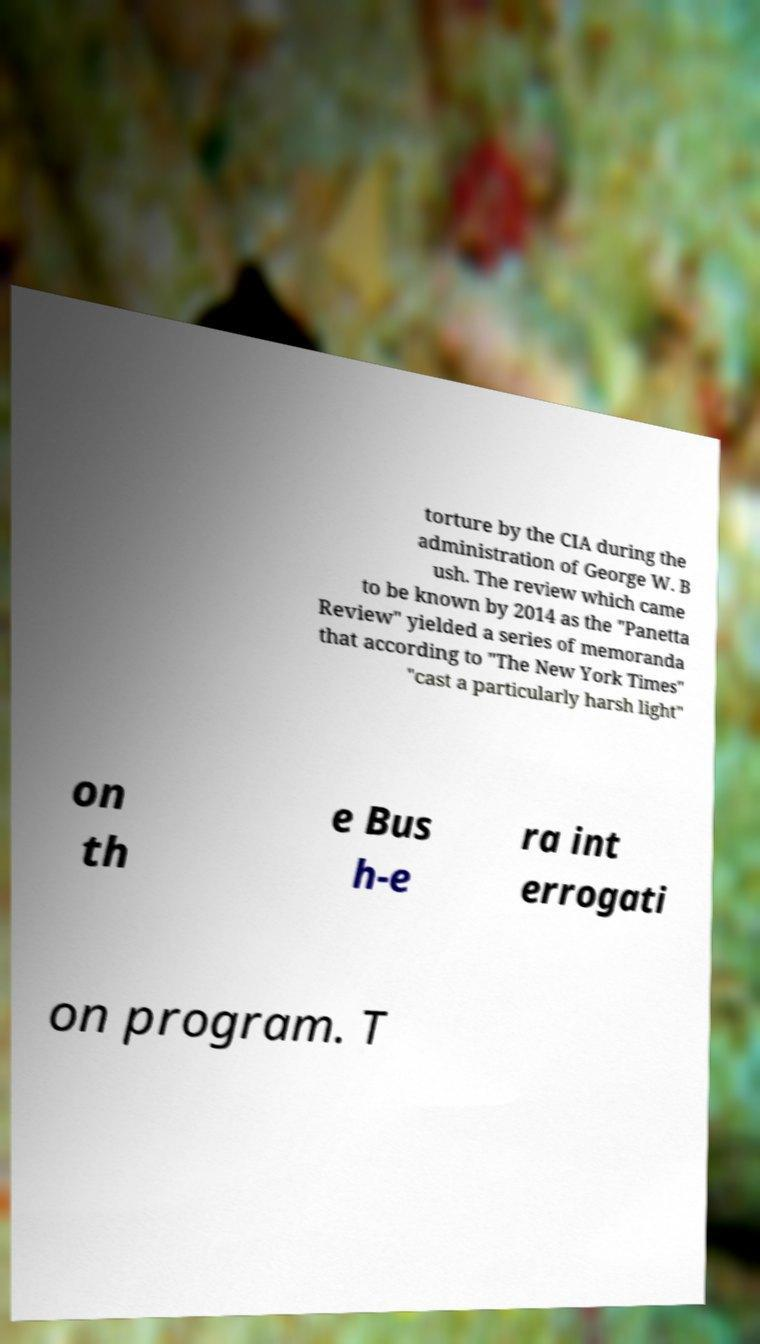Could you extract and type out the text from this image? torture by the CIA during the administration of George W. B ush. The review which came to be known by 2014 as the "Panetta Review" yielded a series of memoranda that according to "The New York Times" "cast a particularly harsh light" on th e Bus h-e ra int errogati on program. T 